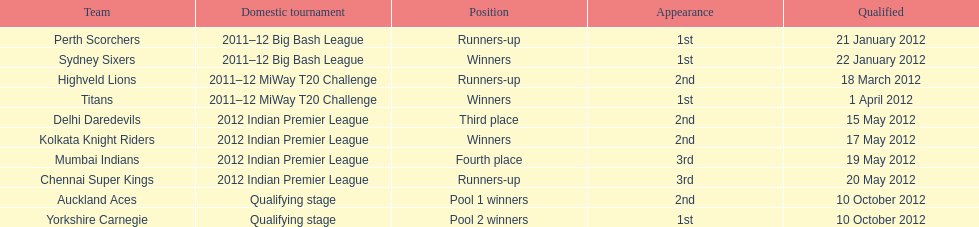What is the total number of teams? 10. 